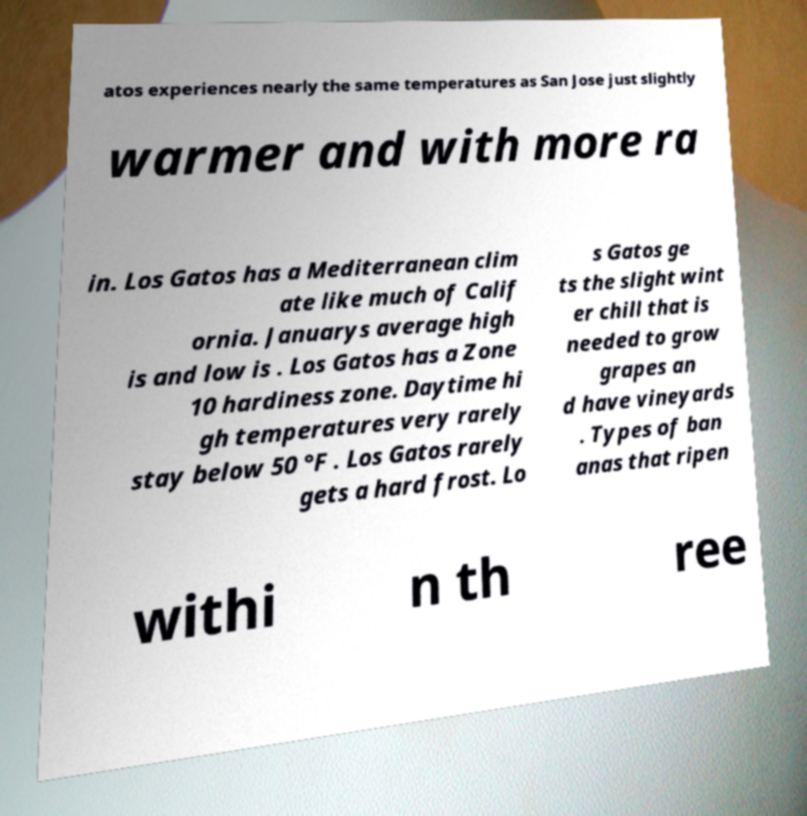Could you assist in decoding the text presented in this image and type it out clearly? atos experiences nearly the same temperatures as San Jose just slightly warmer and with more ra in. Los Gatos has a Mediterranean clim ate like much of Calif ornia. Januarys average high is and low is . Los Gatos has a Zone 10 hardiness zone. Daytime hi gh temperatures very rarely stay below 50 °F . Los Gatos rarely gets a hard frost. Lo s Gatos ge ts the slight wint er chill that is needed to grow grapes an d have vineyards . Types of ban anas that ripen withi n th ree 